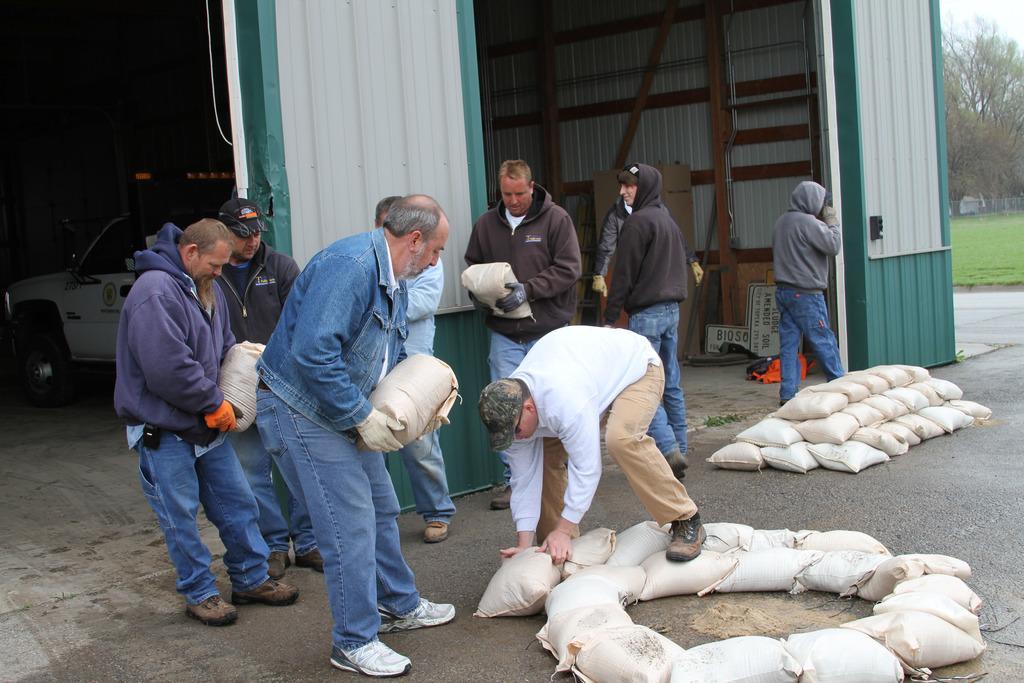Can you describe this image briefly? In this picture I can see few people standing and few are holding bags in their hands and I can see few bags on the ground and looks like a mini truck in the shelter. I can see few trees and grass on the ground in the back. 